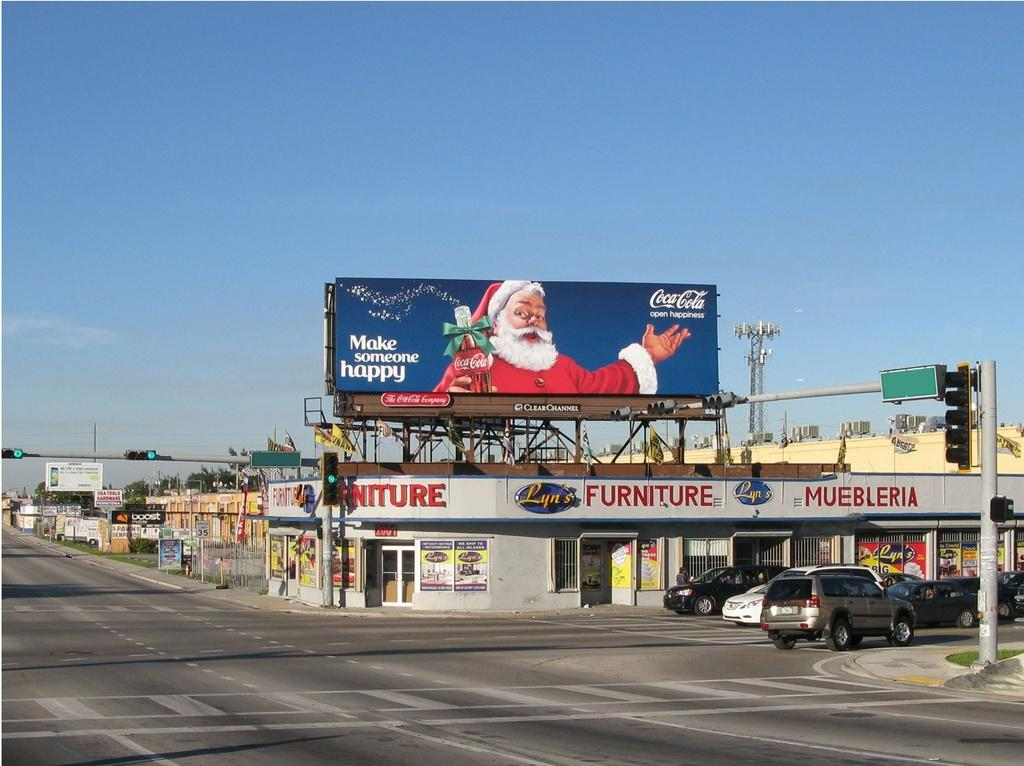What can be seen on the road in the image? There are vehicles on the road in the image. What objects are present in the image that are not vehicles? There are poles, lights, boards, buildings, trees, and boards in the image. What is visible in the background of the image? The sky is visible in the background of the image. What type of cabbage can be seen growing on the trees in the image? There is no cabbage present in the image, and cabbage does not grow on trees. 